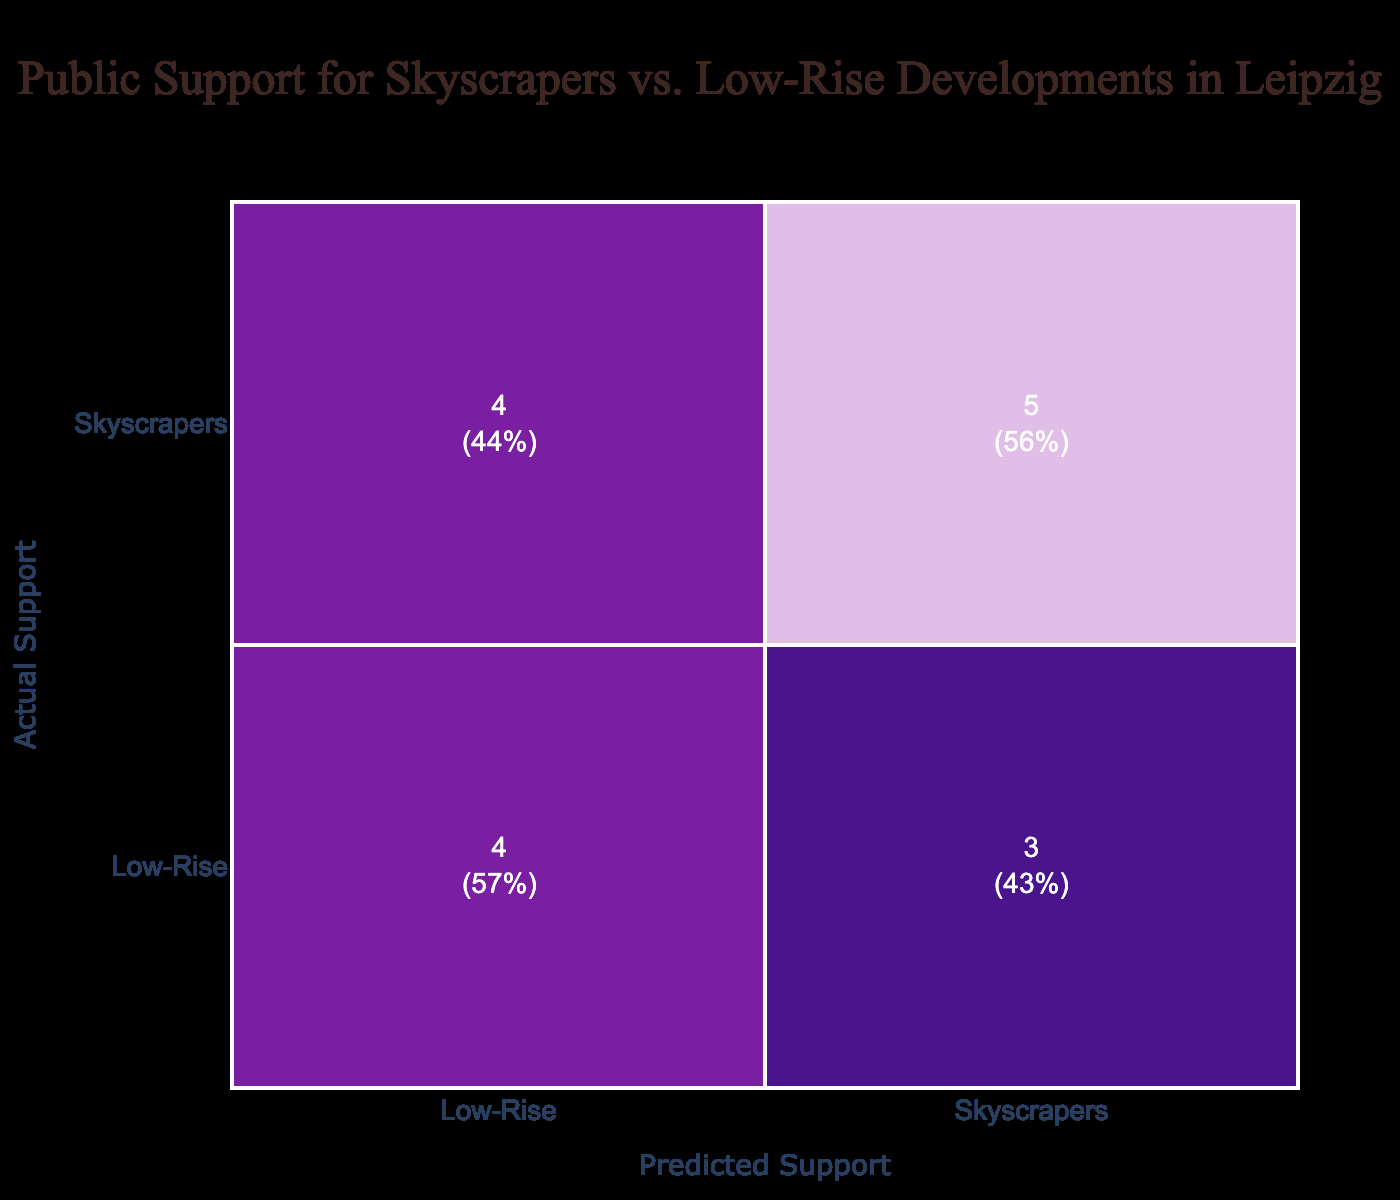What is the total number of responses that supported Skyscrapers? There are 8 instances where the actual support is for Skyscrapers, as identified in the rows of the confusion matrix.
Answer: 8 What is the percentage of people who actually supported Low-Rise developments and predicted the same? Out of the 7 instances where the actual support was for Low-Rise, 4 were also predicted as Low-Rise. The percentage is therefore calculated as (4/7) * 100 = approximately 57%.
Answer: 57% How many instances incorrectly predicted support for Skyscrapers when the actual support was for Low-Rise? There are 3 instances where the actual support was for Low-Rise but were predicted as Skyscrapers, which can be counted from the confusion matrix.
Answer: 3 Is the prediction for Skyscrapers more accurate than for Low-Rise developments? Yes, Skyscrapers show 6 correct predictions out of 8 (75%), while Low-Rise has 4 correct predictions out of 7 (approximately 57%). Thus, Skyscrapers have a higher prediction accuracy.
Answer: Yes What is the total number of incorrect predictions for Low-Rise developments? There are 3 incorrect predictions for Low-Rise developments, where the actual support was Low-Rise but predicted as Skyscrapers. Thus, adding those instances gives the total of 3.
Answer: 3 What is the ratio of correct predictions for Skyscrapers to total predictions for Skyscrapers? There are 6 correct predictions for Skyscrapers out of a total of 8 predictions for Skyscrapers, hence the ratio is 6:8, which simplifies to 3:4.
Answer: 3:4 How many people supported Skyscrapers but were predicted to support Low-Rise developments? There are 3 instances where individuals supported Skyscrapers, yet were incorrectly predicted to prefer Low-Rise developments, as observed in the confusion matrix.
Answer: 3 What is the average support for Skyscrapers across all predictions? There are 8 total instances of predicted support for Skyscrapers out of a sampling of 15. Hence, the average support can be computed as 8/15 which is approximately 0.53 or 53%.
Answer: 53% 